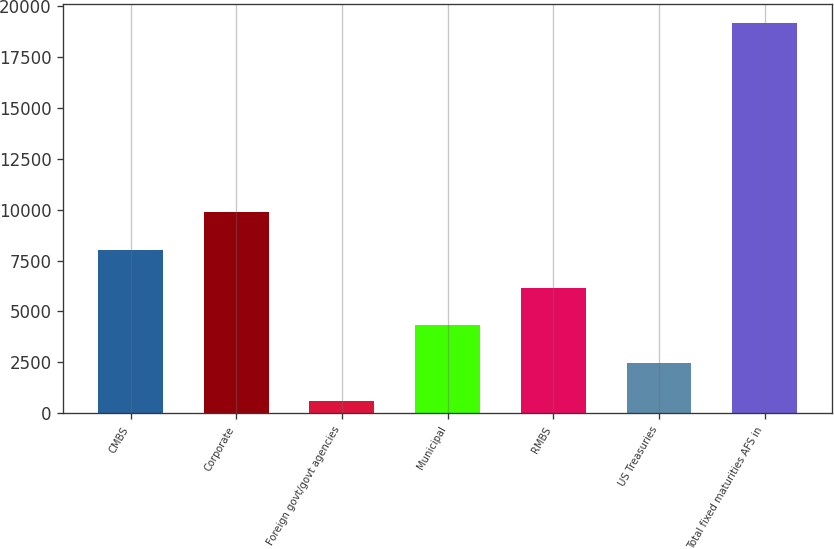Convert chart to OTSL. <chart><loc_0><loc_0><loc_500><loc_500><bar_chart><fcel>CMBS<fcel>Corporate<fcel>Foreign govt/govt agencies<fcel>Municipal<fcel>RMBS<fcel>US Treasuries<fcel>Total fixed maturities AFS in<nl><fcel>8028.8<fcel>9883.5<fcel>610<fcel>4319.4<fcel>6174.1<fcel>2464.7<fcel>19157<nl></chart> 